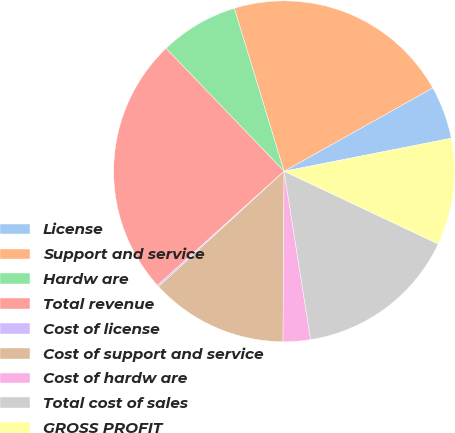Convert chart to OTSL. <chart><loc_0><loc_0><loc_500><loc_500><pie_chart><fcel>License<fcel>Support and service<fcel>Hardw are<fcel>Total revenue<fcel>Cost of license<fcel>Cost of support and service<fcel>Cost of hardw are<fcel>Total cost of sales<fcel>GROSS PROFIT<nl><fcel>5.03%<fcel>21.59%<fcel>7.46%<fcel>24.49%<fcel>0.16%<fcel>13.07%<fcel>2.59%<fcel>15.5%<fcel>10.12%<nl></chart> 